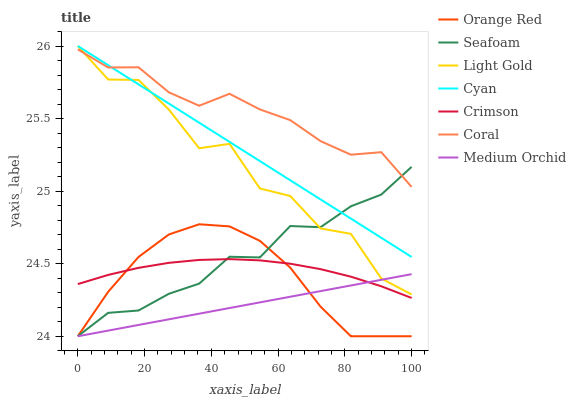Does Seafoam have the minimum area under the curve?
Answer yes or no. No. Does Seafoam have the maximum area under the curve?
Answer yes or no. No. Is Medium Orchid the smoothest?
Answer yes or no. No. Is Medium Orchid the roughest?
Answer yes or no. No. Does Crimson have the lowest value?
Answer yes or no. No. Does Seafoam have the highest value?
Answer yes or no. No. Is Medium Orchid less than Cyan?
Answer yes or no. Yes. Is Light Gold greater than Crimson?
Answer yes or no. Yes. Does Medium Orchid intersect Cyan?
Answer yes or no. No. 